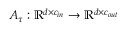Convert formula to latex. <formula><loc_0><loc_0><loc_500><loc_500>A _ { \tau } \colon \mathbb { R } ^ { d \times c _ { i n } } \rightarrow \mathbb { R } ^ { d \times c _ { o u t } }</formula> 